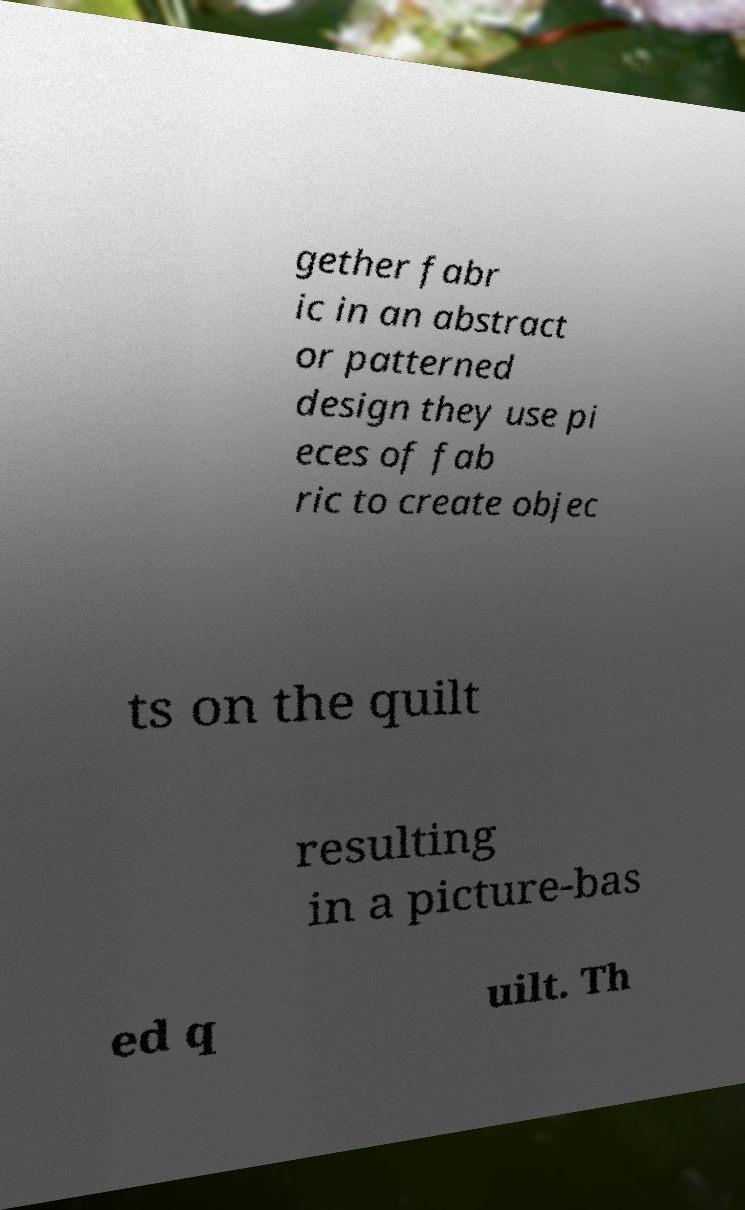Could you extract and type out the text from this image? gether fabr ic in an abstract or patterned design they use pi eces of fab ric to create objec ts on the quilt resulting in a picture-bas ed q uilt. Th 